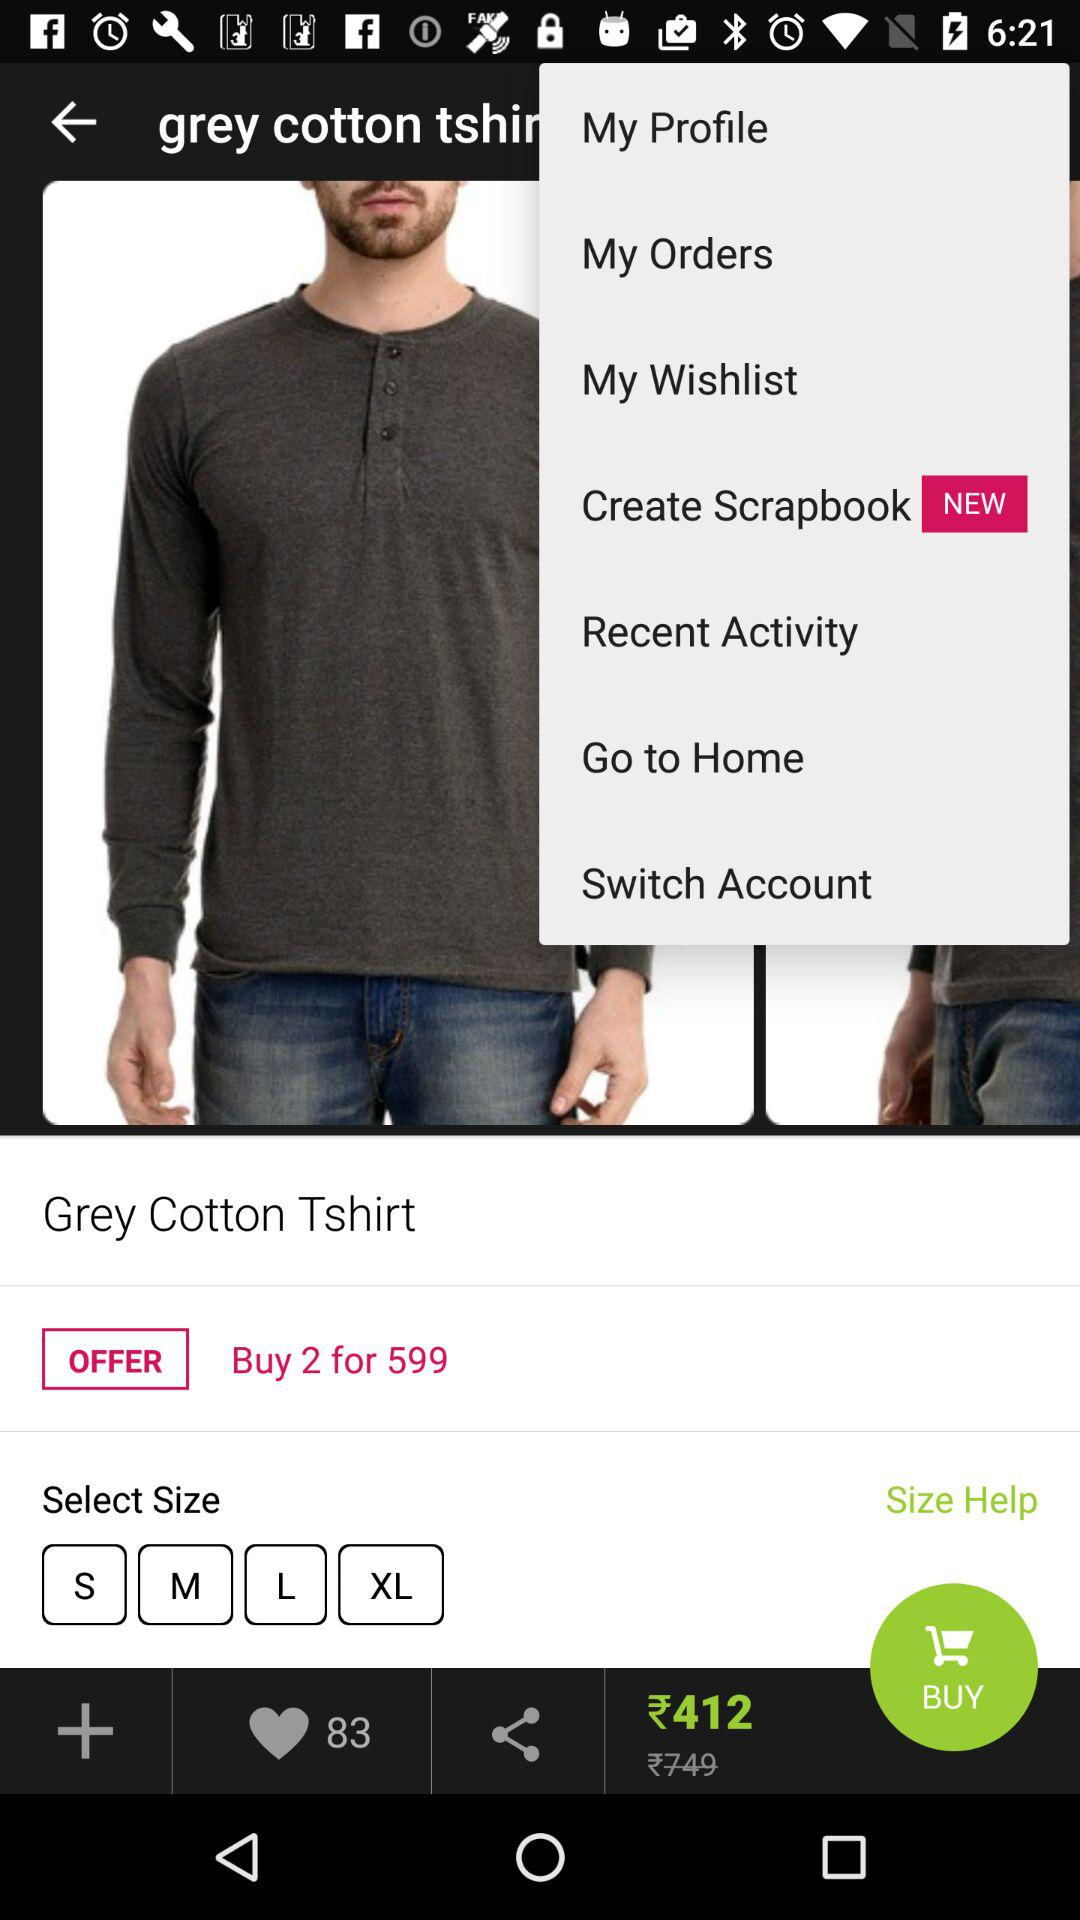How many likes are there for the "Grey Cotton Tshirt"? There are 83 likes for the "Grey Cotton Tshirt". 